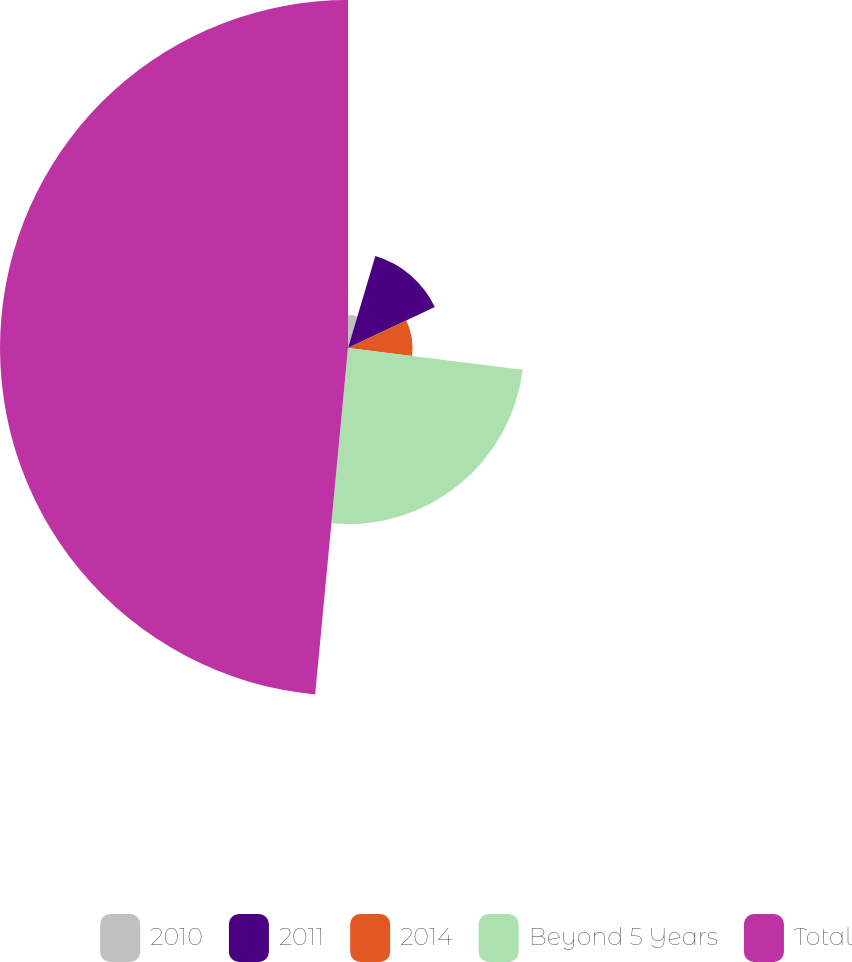Convert chart. <chart><loc_0><loc_0><loc_500><loc_500><pie_chart><fcel>2010<fcel>2011<fcel>2014<fcel>Beyond 5 Years<fcel>Total<nl><fcel>4.6%<fcel>13.38%<fcel>8.99%<fcel>24.54%<fcel>48.5%<nl></chart> 